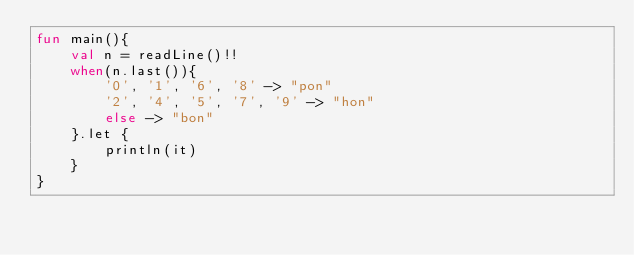Convert code to text. <code><loc_0><loc_0><loc_500><loc_500><_Kotlin_>fun main(){
    val n = readLine()!!
    when(n.last()){
        '0', '1', '6', '8' -> "pon"
        '2', '4', '5', '7', '9' -> "hon"
        else -> "bon"
    }.let {
        println(it)
    }
}</code> 